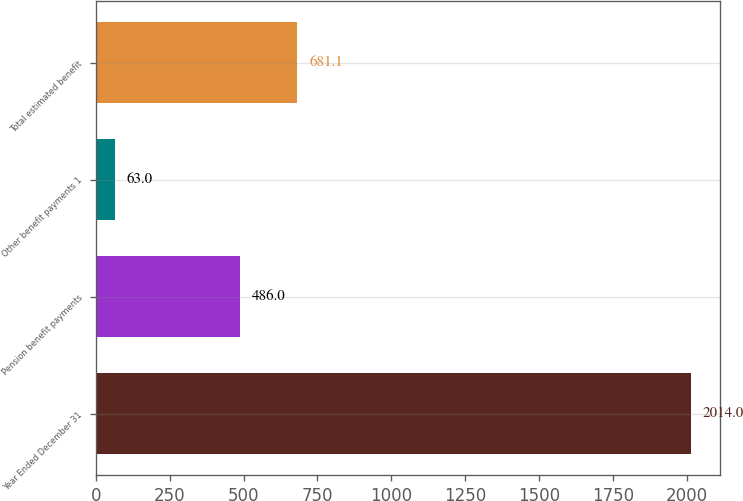Convert chart. <chart><loc_0><loc_0><loc_500><loc_500><bar_chart><fcel>Year Ended December 31<fcel>Pension benefit payments<fcel>Other benefit payments 1<fcel>Total estimated benefit<nl><fcel>2014<fcel>486<fcel>63<fcel>681.1<nl></chart> 